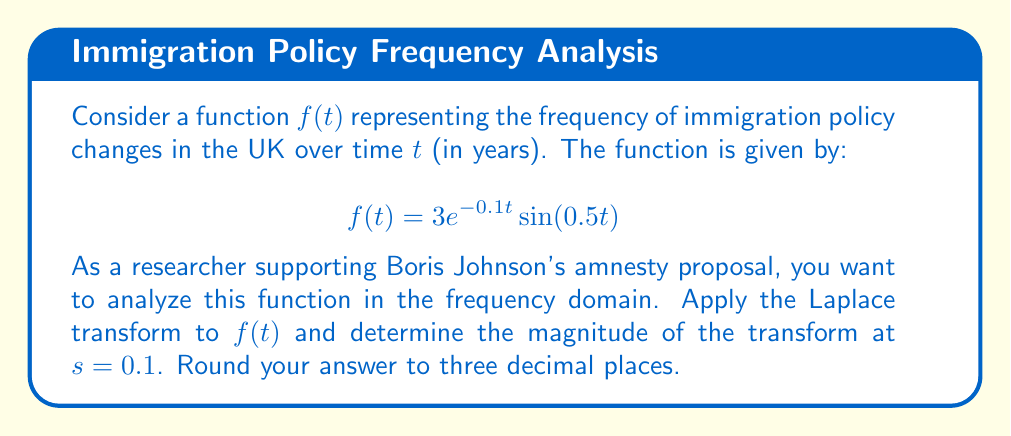Solve this math problem. To solve this problem, we'll follow these steps:

1) Recall the Laplace transform of $e^{at}\sin(bt)$:
   $$\mathcal{L}\{e^{at}\sin(bt)\} = \frac{b}{(s-a)^2 + b^2}$$

2) In our case, $a = -0.1$ and $b = 0.5$. We also have a factor of 3. So our transform will be:
   $$F(s) = \mathcal{L}\{f(t)\} = 3 \cdot \frac{0.5}{(s+0.1)^2 + 0.5^2}$$

3) Simplify:
   $$F(s) = \frac{1.5}{(s+0.1)^2 + 0.25}$$

4) We need to find $|F(0.1)|$. Substitute $s = 0.1$:
   $$F(0.1) = \frac{1.5}{(0.1+0.1)^2 + 0.25} = \frac{1.5}{0.04 + 0.25} = \frac{1.5}{0.29}$$

5) Calculate the magnitude:
   $$|F(0.1)| = \left|\frac{1.5}{0.29}\right| = \frac{1.5}{0.29} \approx 5.172$$

6) Rounding to three decimal places:
   $$|F(0.1)| \approx 5.172$$
Answer: $5.172$ 